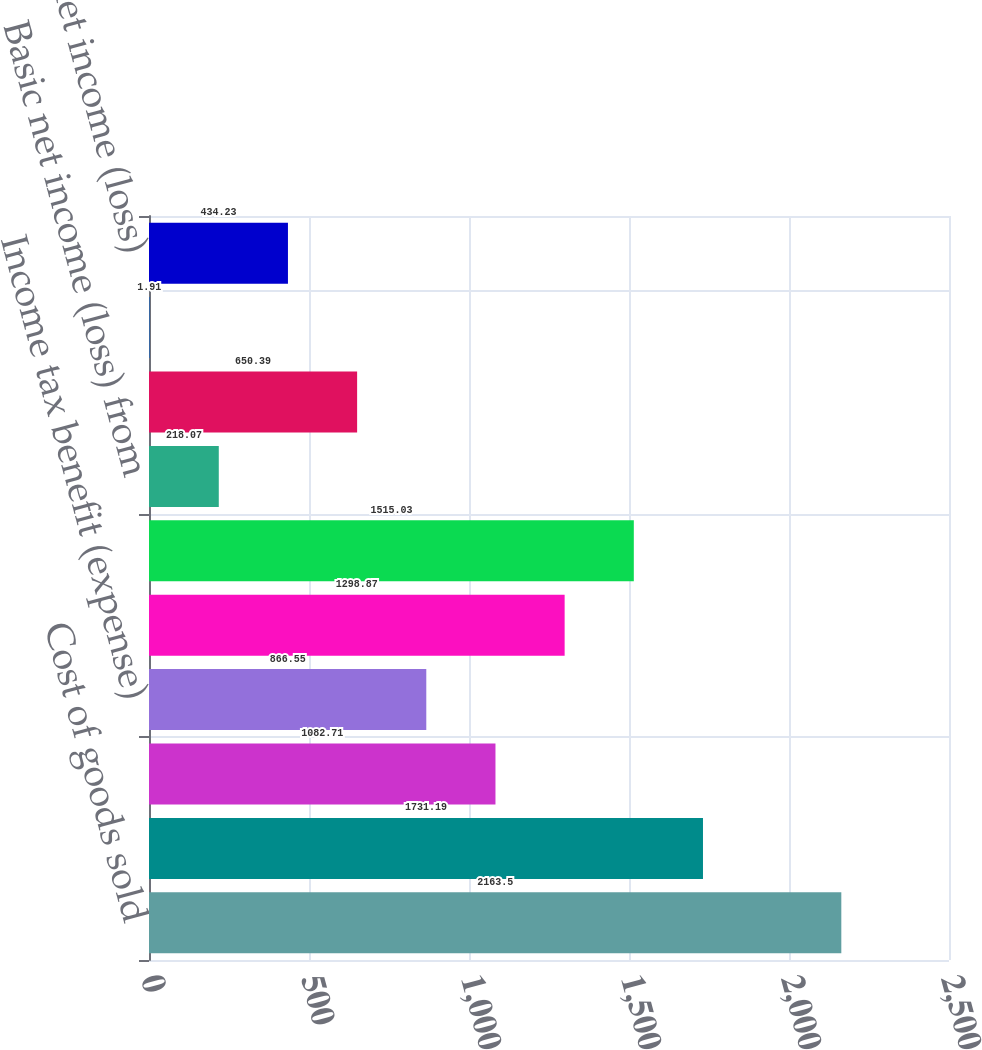Convert chart to OTSL. <chart><loc_0><loc_0><loc_500><loc_500><bar_chart><fcel>Cost of goods sold<fcel>Marketing general and<fcel>Special items net<fcel>Income tax benefit (expense)<fcel>Net income (loss) from<fcel>Net income (loss) attributable<fcel>Basic net income (loss) from<fcel>Basic net income (loss)<fcel>Diluted net income (loss) from<fcel>Diluted net income (loss)<nl><fcel>2163.5<fcel>1731.19<fcel>1082.71<fcel>866.55<fcel>1298.87<fcel>1515.03<fcel>218.07<fcel>650.39<fcel>1.91<fcel>434.23<nl></chart> 